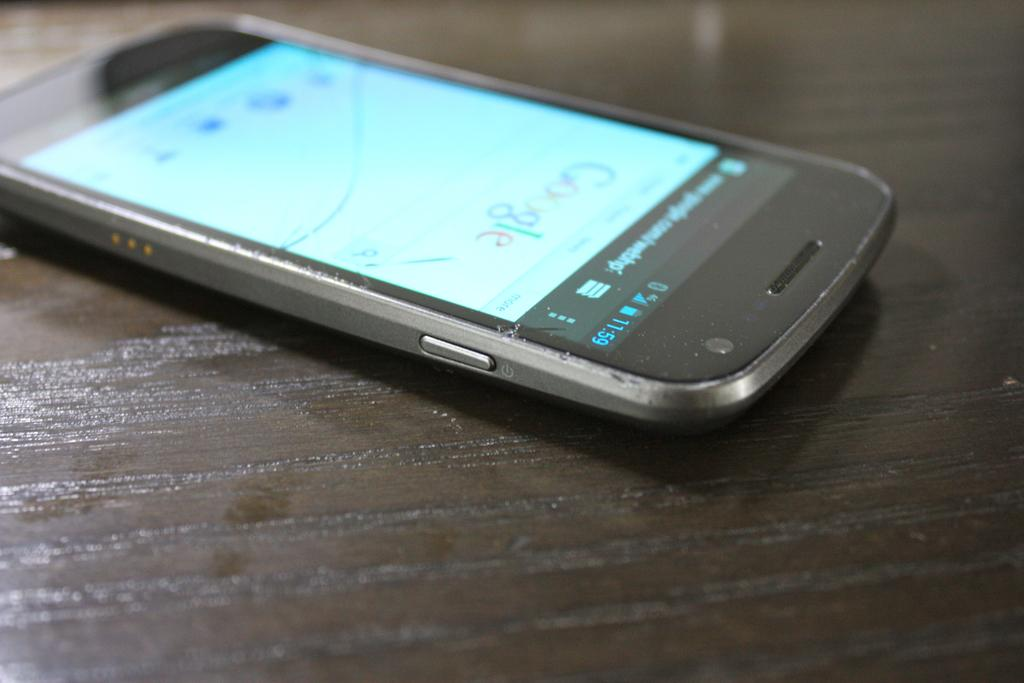<image>
Offer a succinct explanation of the picture presented. An electronic device open to the Google home page. 